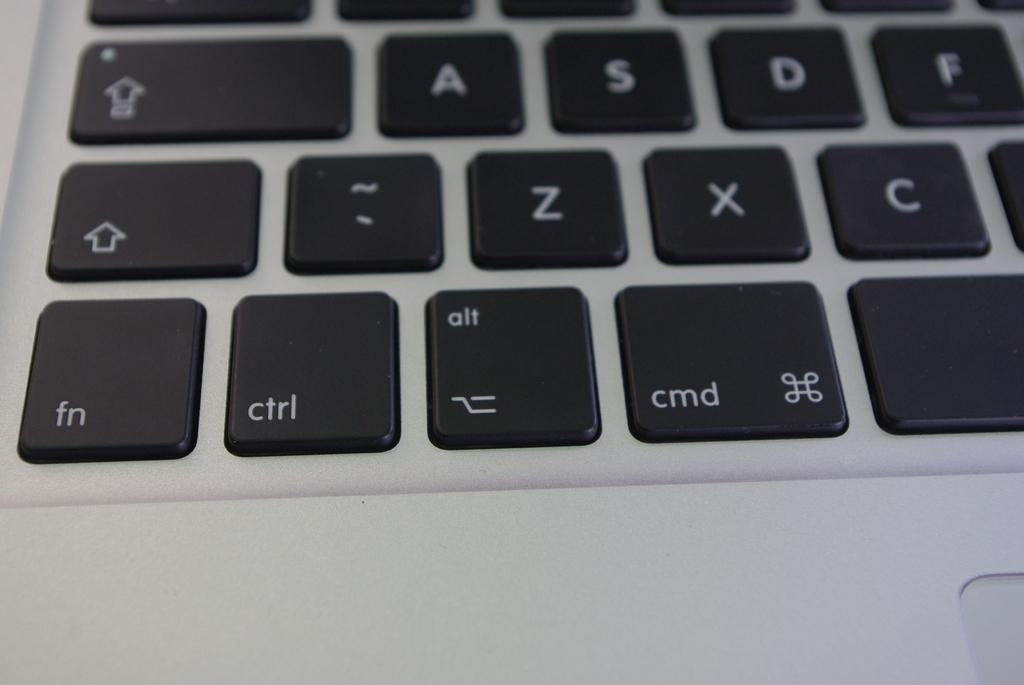Provide a one-sentence caption for the provided image. The visible keys on a keyboard include ctrl, fn and cmd. 